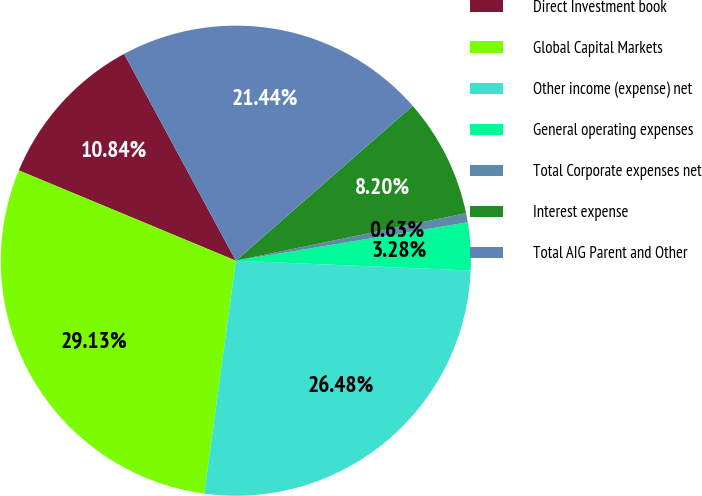<chart> <loc_0><loc_0><loc_500><loc_500><pie_chart><fcel>Direct Investment book<fcel>Global Capital Markets<fcel>Other income (expense) net<fcel>General operating expenses<fcel>Total Corporate expenses net<fcel>Interest expense<fcel>Total AIG Parent and Other<nl><fcel>10.84%<fcel>29.13%<fcel>26.48%<fcel>3.28%<fcel>0.63%<fcel>8.2%<fcel>21.44%<nl></chart> 